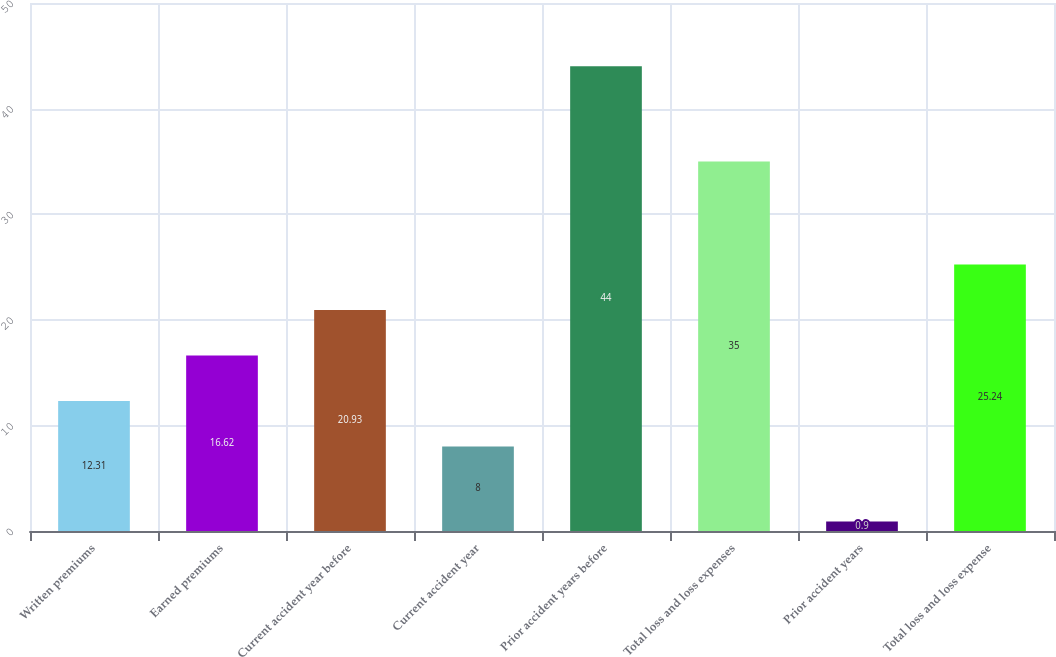Convert chart. <chart><loc_0><loc_0><loc_500><loc_500><bar_chart><fcel>Written premiums<fcel>Earned premiums<fcel>Current accident year before<fcel>Current accident year<fcel>Prior accident years before<fcel>Total loss and loss expenses<fcel>Prior accident years<fcel>Total loss and loss expense<nl><fcel>12.31<fcel>16.62<fcel>20.93<fcel>8<fcel>44<fcel>35<fcel>0.9<fcel>25.24<nl></chart> 